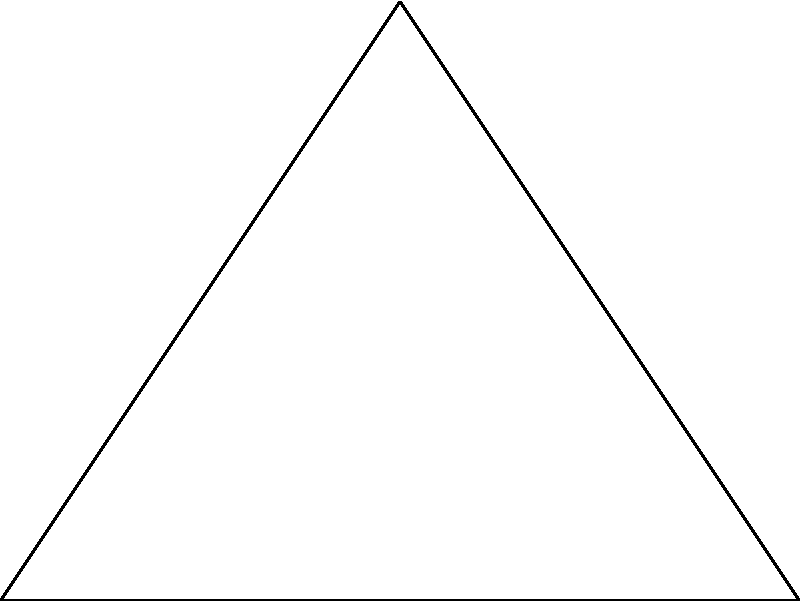In analyzing the geometric patterns of a Fabergé egg design, you encounter a triangular motif. The triangle has sides of length 3, 4, and 5 units. Determine if this triangle is congruent to a right-angled triangle with the same side lengths. To determine if the triangles are congruent, we need to follow these steps:

1. Recall the Pythagorean theorem: In a right-angled triangle, $a^2 + b^2 = c^2$, where $c$ is the length of the hypotenuse (longest side).

2. Check if the given triangle satisfies the Pythagorean theorem:
   Let's assume the longest side (5) is the hypotenuse.
   $3^2 + 4^2 = 9 + 16 = 25$
   $5^2 = 25$

3. Since $3^2 + 4^2 = 5^2$, the given triangle is indeed a right-angled triangle.

4. The definition of congruence states that two triangles are congruent if they have the same shape and size, i.e., all corresponding sides and angles are equal.

5. Both triangles have sides of length 3, 4, and 5 units, and both are right-angled triangles.

Therefore, the triangular motif in the Fabergé egg design is congruent to a right-angled triangle with the same side lengths.
Answer: Yes, congruent 